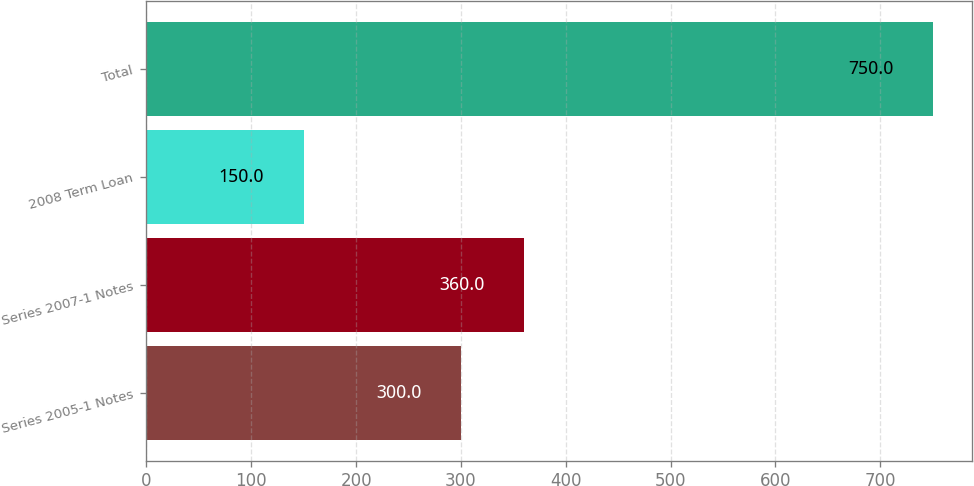Convert chart. <chart><loc_0><loc_0><loc_500><loc_500><bar_chart><fcel>Series 2005-1 Notes<fcel>Series 2007-1 Notes<fcel>2008 Term Loan<fcel>Total<nl><fcel>300<fcel>360<fcel>150<fcel>750<nl></chart> 